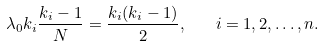<formula> <loc_0><loc_0><loc_500><loc_500>\lambda _ { 0 } k _ { i } \frac { k _ { i } - 1 } { N } = \frac { k _ { i } ( k _ { i } - 1 ) } { 2 } , \quad i = 1 , 2 , \dots , n .</formula> 